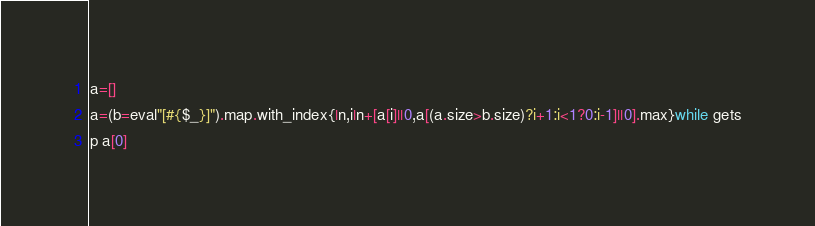Convert code to text. <code><loc_0><loc_0><loc_500><loc_500><_Ruby_>a=[]
a=(b=eval"[#{$_}]").map.with_index{|n,i|n+[a[i]||0,a[(a.size>b.size)?i+1:i<1?0:i-1]||0].max}while gets
p a[0]</code> 